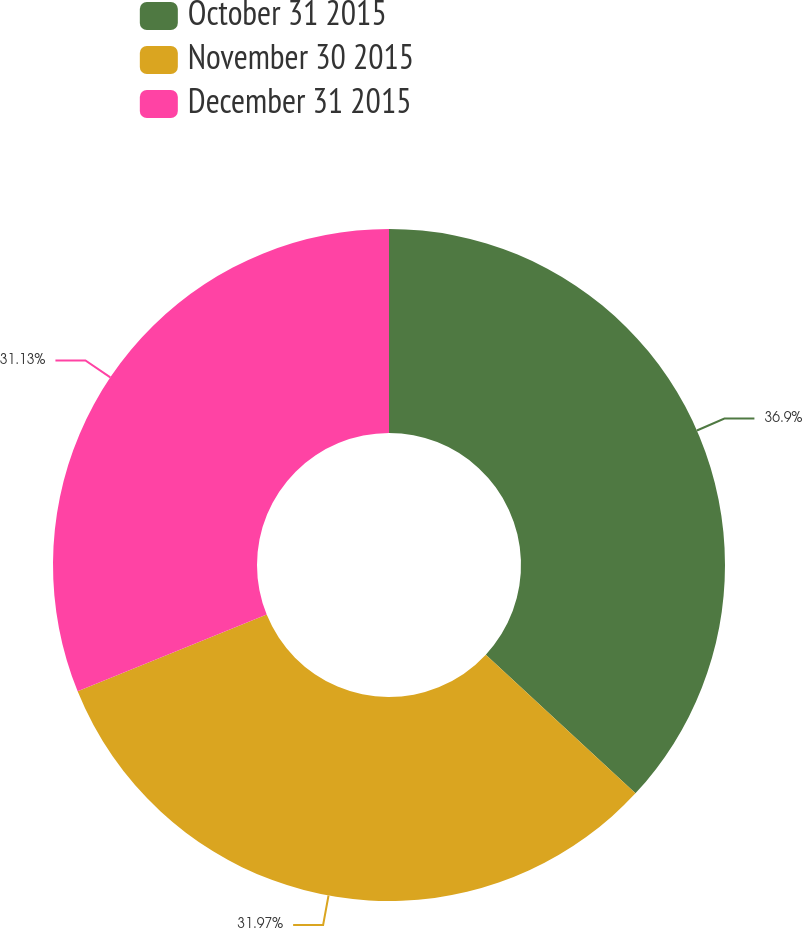<chart> <loc_0><loc_0><loc_500><loc_500><pie_chart><fcel>October 31 2015<fcel>November 30 2015<fcel>December 31 2015<nl><fcel>36.89%<fcel>31.97%<fcel>31.13%<nl></chart> 